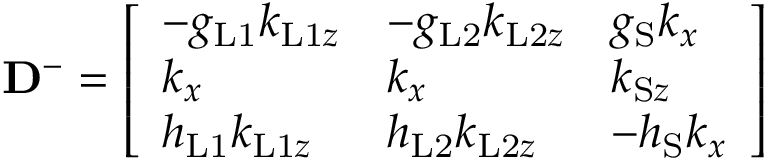<formula> <loc_0><loc_0><loc_500><loc_500>D ^ { - } = \left [ \begin{array} { l l l } { - g _ { L 1 } k _ { L 1 z } } & { - g _ { L 2 } k _ { L 2 z } } & { g _ { S } k _ { x } } \\ { k _ { x } } & { k _ { x } } & { k _ { S z } } \\ { h _ { L 1 } k _ { L 1 z } } & { h _ { L 2 } k _ { L 2 z } } & { - h _ { S } k _ { x } } \end{array} \right ]</formula> 